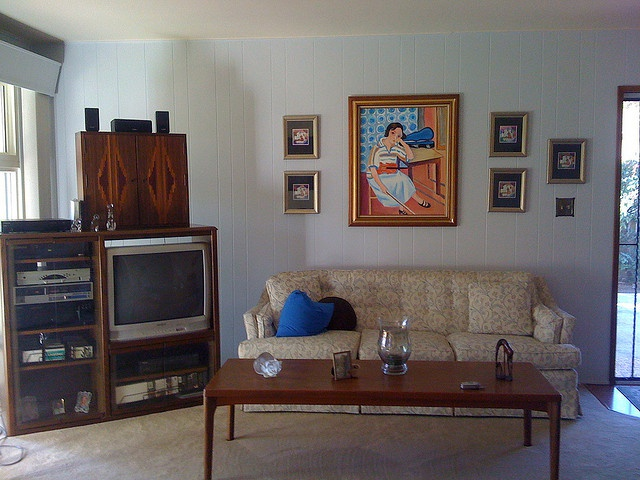Describe the objects in this image and their specific colors. I can see couch in darkgray, gray, and black tones, tv in darkgray, black, and gray tones, and vase in darkgray, gray, and black tones in this image. 